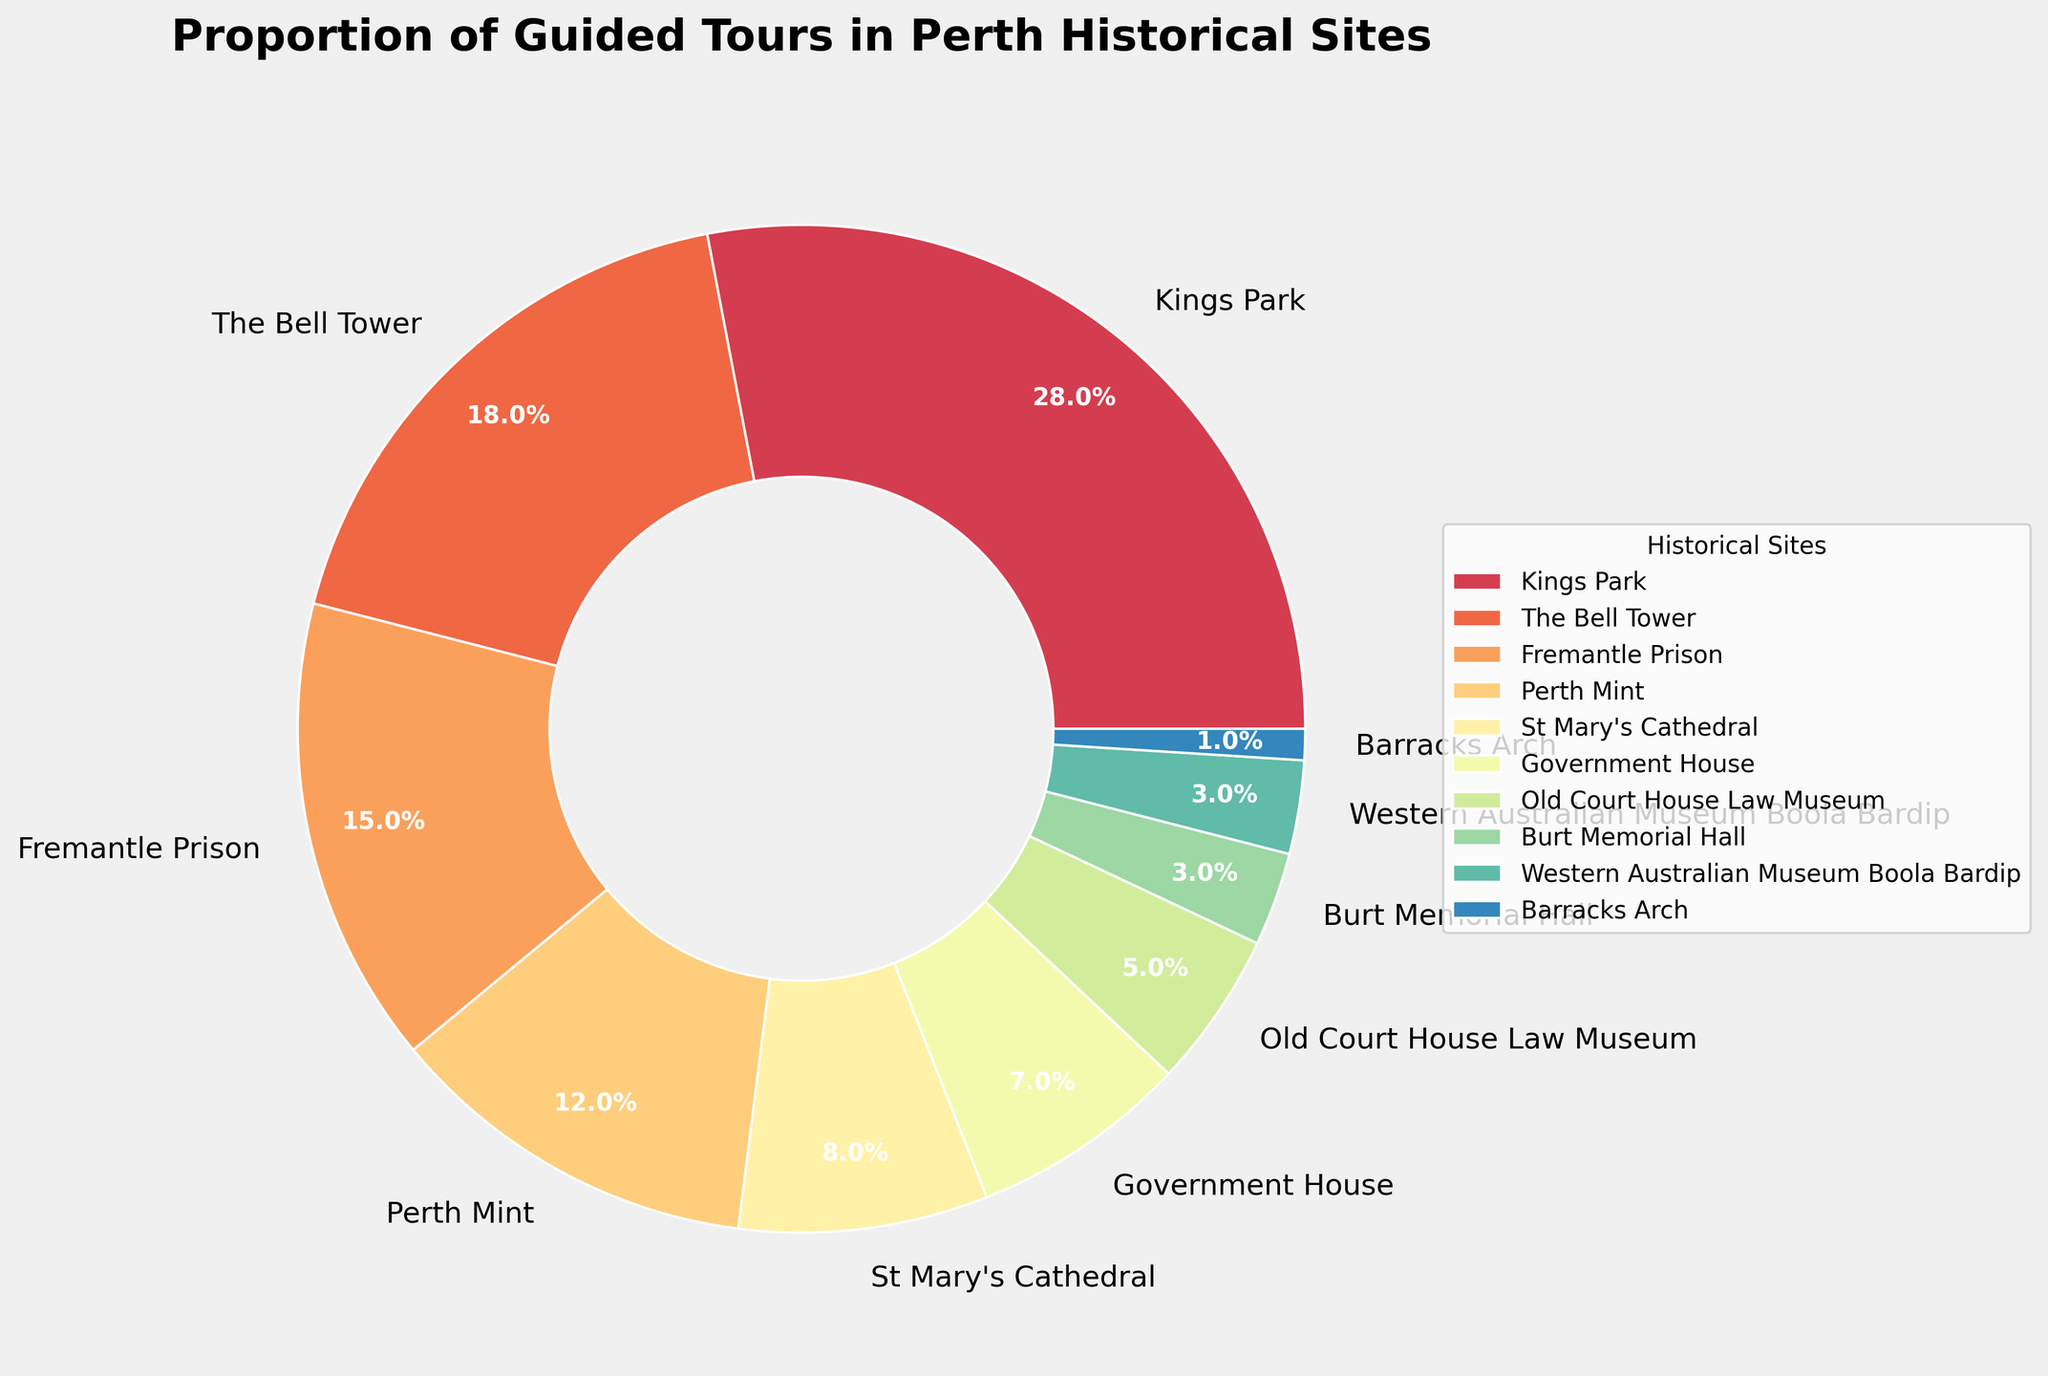Which historical site has the highest proportion of guided tours? From the pie chart, we see that Kings Park has the largest slice when compared to the other sites.
Answer: Kings Park Which historical site has the smallest proportion of guided tours? From the pie chart, Barracks Arch has the smallest slice when compared to the other sites.
Answer: Barracks Arch What is the combined percentage of guided tours conducted at The Bell Tower and Fremantle Prison? From the pie chart, The Bell Tower accounts for 18% and Fremantle Prison accounts for 15%. Adding these together: 18% + 15% = 33%.
Answer: 33% Is the proportion of guided tours at Perth Mint greater than at St Mary's Cathedral? By looking at the pie chart, the slice for Perth Mint (12%) is larger than the slice for St Mary's Cathedral (8%).
Answer: Yes Compare the proportion of guided tours at Government House and Old Court House Law Museum. Which is greater? By examining the pie chart, the slice for Government House (7%) is larger than the slice for Old Court House Law Museum (5%).
Answer: Government House What is the total proportion of guided tours conducted at Kings Park, The Bell Tower, and Fremantle Prison? From the pie chart, Kings Park is 28%, The Bell Tower is 18%, and Fremantle Prison is 15%. Adding these together: 28% + 18% + 15% = 61%.
Answer: 61% What is the difference in the proportion of guided tours between Kings Park and Perth Mint? From the pie chart, Kings Park accounts for 28% and Perth Mint accounts for 12%. The difference is: 28% - 12% = 16%.
Answer: 16% Which two historical sites have an equal proportion of guided tours, and what is that proportion? By looking at the pie chart, it is evident that Burt Memorial Hall and Western Australian Museum Boola Bardip both have slices representing 3%.
Answer: Burt Memorial Hall and Western Australian Museum Boola Bardip, 3% How many historical sites have a proportion of guided tours greater than 10%? From the pie chart, the following sites have proportions greater than 10%: Kings Park (28%), The Bell Tower (18%), Fremantle Prison (15%), and Perth Mint (12%). This totals to 4 sites.
Answer: 4 What is the total proportion of guided tours conducted at St Mary's Cathedral, Government House, and Old Court House Law Museum? From the pie chart, St Mary's Cathedral is 8%, Government House is 7%, and Old Court House Law Museum is 5%. Adding these together: 8% + 7% + 5% = 20%.
Answer: 20% 